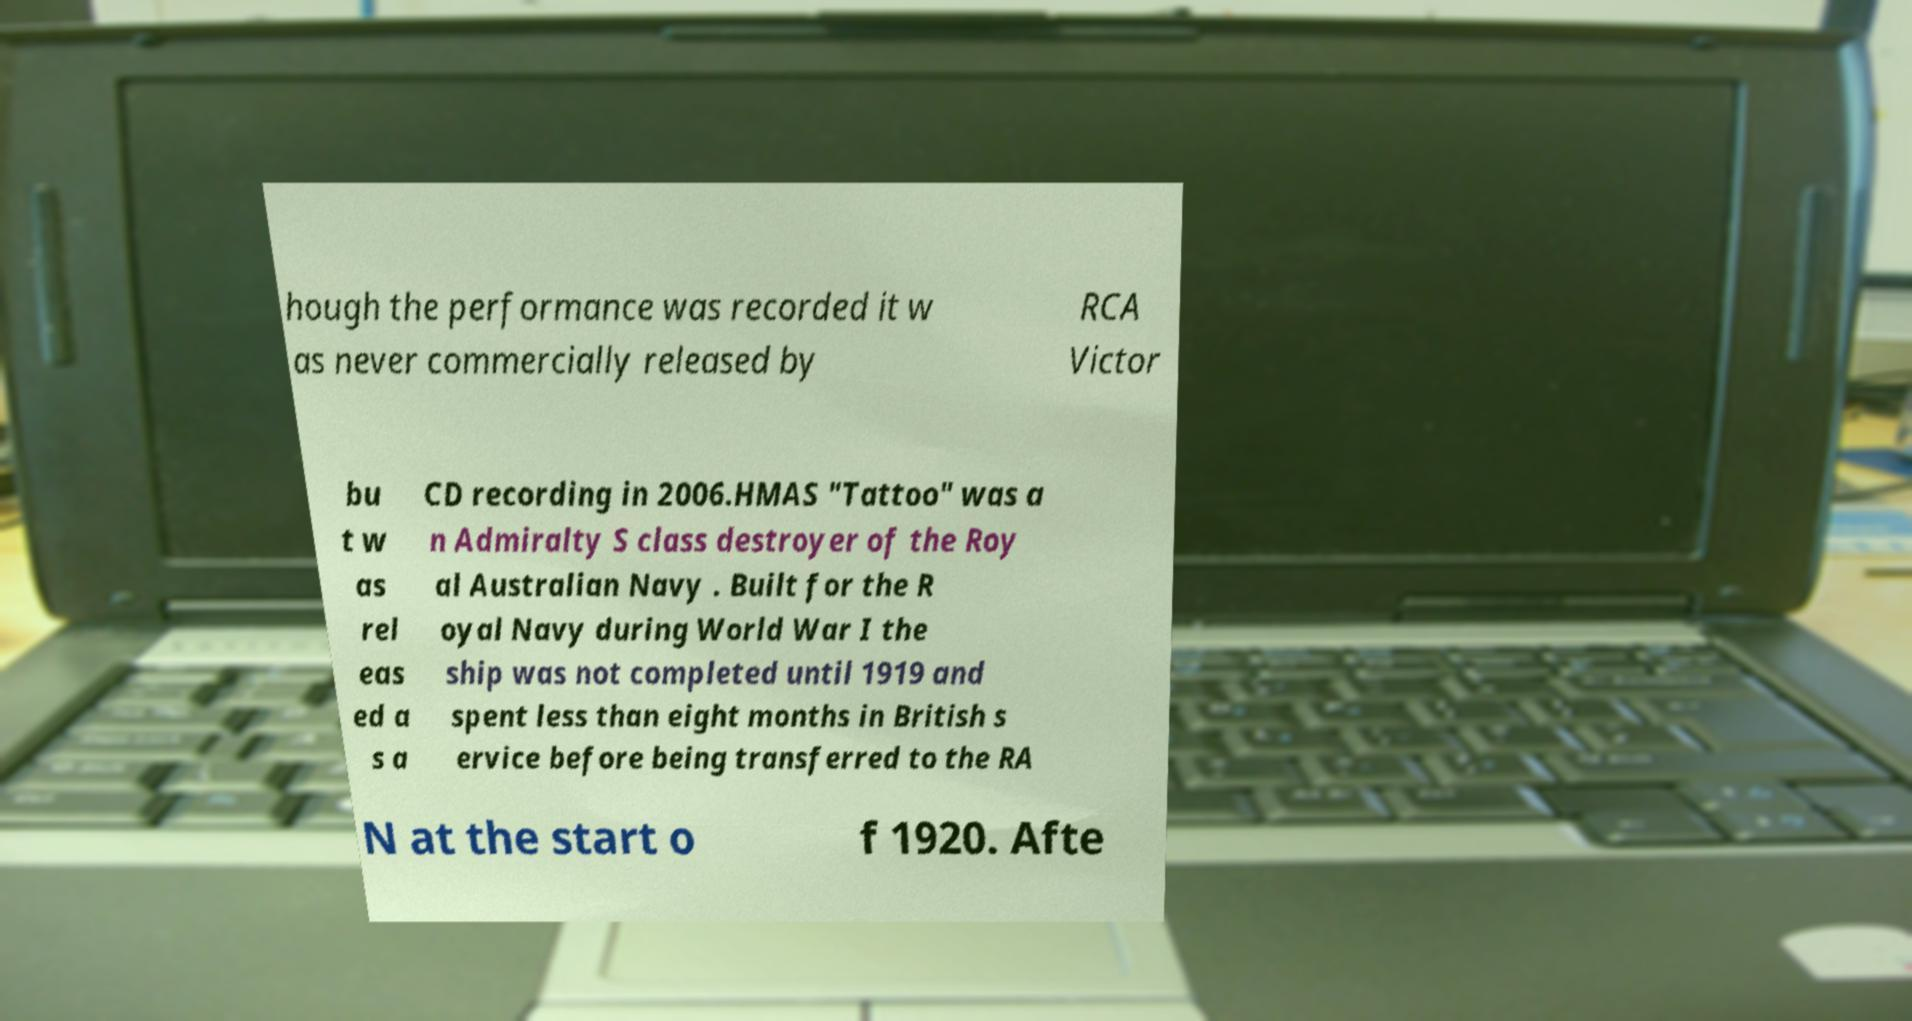Could you assist in decoding the text presented in this image and type it out clearly? hough the performance was recorded it w as never commercially released by RCA Victor bu t w as rel eas ed a s a CD recording in 2006.HMAS "Tattoo" was a n Admiralty S class destroyer of the Roy al Australian Navy . Built for the R oyal Navy during World War I the ship was not completed until 1919 and spent less than eight months in British s ervice before being transferred to the RA N at the start o f 1920. Afte 